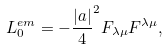<formula> <loc_0><loc_0><loc_500><loc_500>L _ { 0 } ^ { e m } = - \frac { | a | } { 4 } ^ { 2 } F _ { \lambda \mu } F ^ { \lambda \mu } ,</formula> 